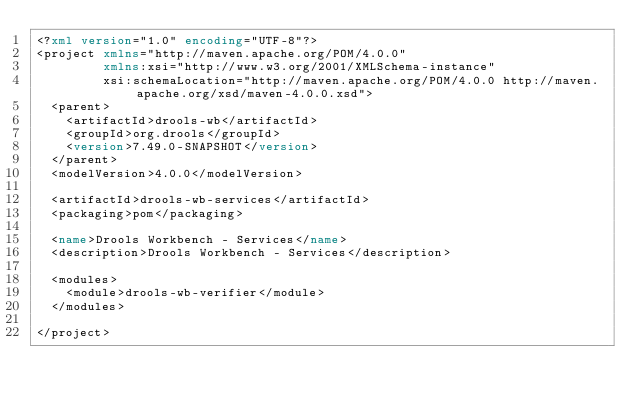<code> <loc_0><loc_0><loc_500><loc_500><_XML_><?xml version="1.0" encoding="UTF-8"?>
<project xmlns="http://maven.apache.org/POM/4.0.0"
         xmlns:xsi="http://www.w3.org/2001/XMLSchema-instance"
         xsi:schemaLocation="http://maven.apache.org/POM/4.0.0 http://maven.apache.org/xsd/maven-4.0.0.xsd">
  <parent>
    <artifactId>drools-wb</artifactId>
    <groupId>org.drools</groupId>
    <version>7.49.0-SNAPSHOT</version>
  </parent>
  <modelVersion>4.0.0</modelVersion>

  <artifactId>drools-wb-services</artifactId>
  <packaging>pom</packaging>

  <name>Drools Workbench - Services</name>
  <description>Drools Workbench - Services</description>

  <modules>
    <module>drools-wb-verifier</module>
  </modules>

</project>
</code> 